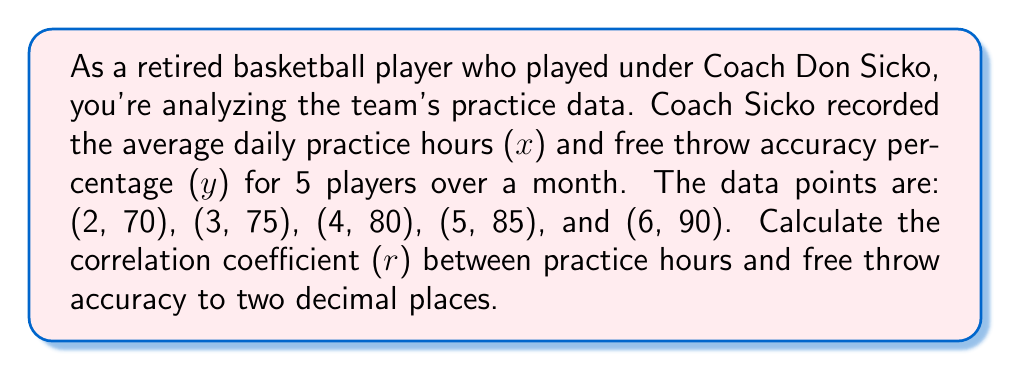Provide a solution to this math problem. To calculate the correlation coefficient (r), we'll use the formula:

$$ r = \frac{n\sum xy - \sum x \sum y}{\sqrt{[n\sum x^2 - (\sum x)^2][n\sum y^2 - (\sum y)^2]}} $$

Where n is the number of data points.

Step 1: Calculate the sums and squares:
$\sum x = 2 + 3 + 4 + 5 + 6 = 20$
$\sum y = 70 + 75 + 80 + 85 + 90 = 400$
$\sum xy = (2)(70) + (3)(75) + (4)(80) + (5)(85) + (6)(90) = 1630$
$\sum x^2 = 2^2 + 3^2 + 4^2 + 5^2 + 6^2 = 90$
$\sum y^2 = 70^2 + 75^2 + 80^2 + 85^2 + 90^2 = 32150$

Step 2: Apply the formula:

$$ r = \frac{5(1630) - (20)(400)}{\sqrt{[5(90) - (20)^2][5(32150) - (400)^2]}} $$

Step 3: Simplify:

$$ r = \frac{8150 - 8000}{\sqrt{(450 - 400)(160750 - 160000)}} $$

$$ r = \frac{150}{\sqrt{(50)(750)}} = \frac{150}{\sqrt{37500}} = \frac{150}{193.65} $$

Step 4: Calculate the final result:

$$ r \approx 0.7746 $$

Rounding to two decimal places: r ≈ 0.77
Answer: The correlation coefficient (r) between practice hours and free throw accuracy is approximately 0.77. 